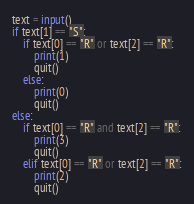<code> <loc_0><loc_0><loc_500><loc_500><_Python_>text = input()
if text[1] == "S":
    if text[0] == "R" or text[2] == "R":
        print(1)
        quit()
    else:
        print(0)
        quit()
else:
    if text[0] == "R" and text[2] == "R":
        print(3)
        quit()
    elif text[0] == "R" or text[2] == "R":
        print(2)
        quit()

</code> 